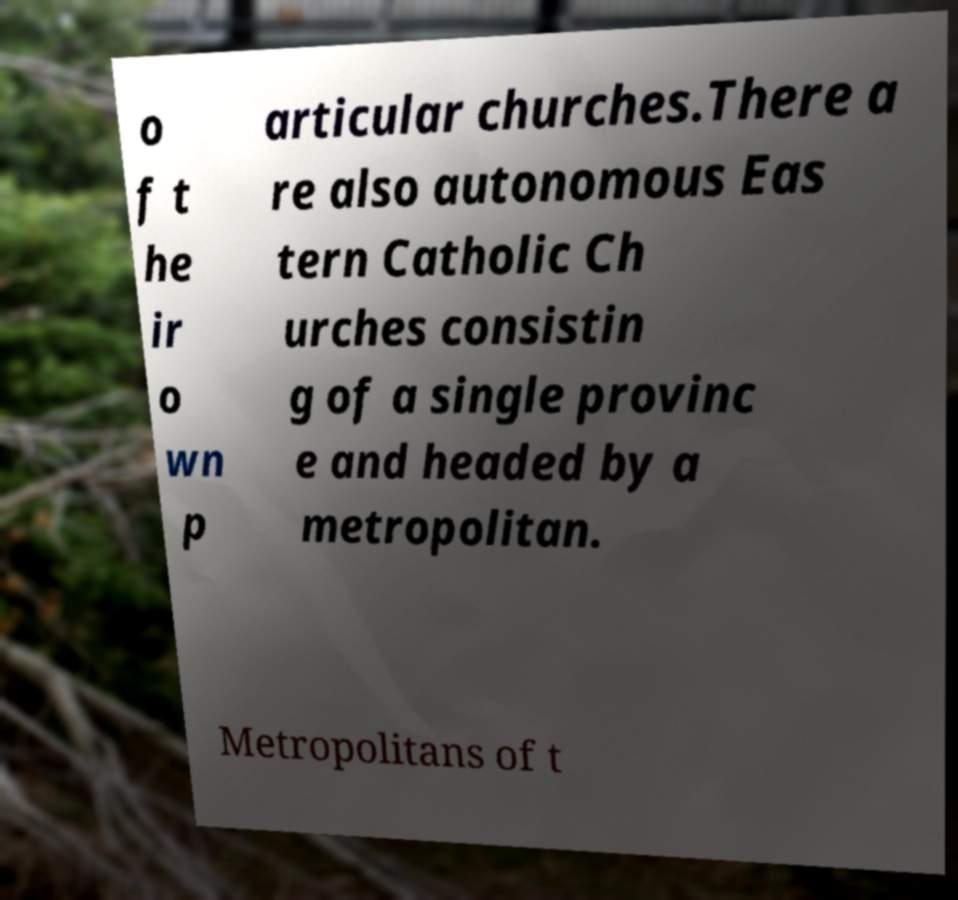There's text embedded in this image that I need extracted. Can you transcribe it verbatim? o f t he ir o wn p articular churches.There a re also autonomous Eas tern Catholic Ch urches consistin g of a single provinc e and headed by a metropolitan. Metropolitans of t 